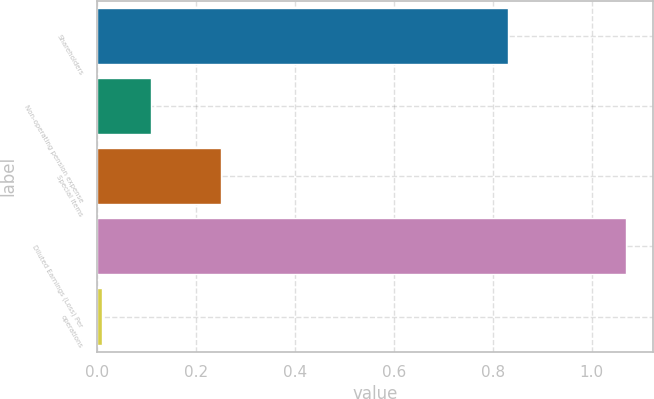Convert chart. <chart><loc_0><loc_0><loc_500><loc_500><bar_chart><fcel>Shareholders<fcel>Non-operating pension expense<fcel>Special items<fcel>Diluted Earnings (Loss) Per<fcel>operations<nl><fcel>0.83<fcel>0.11<fcel>0.25<fcel>1.07<fcel>0.01<nl></chart> 